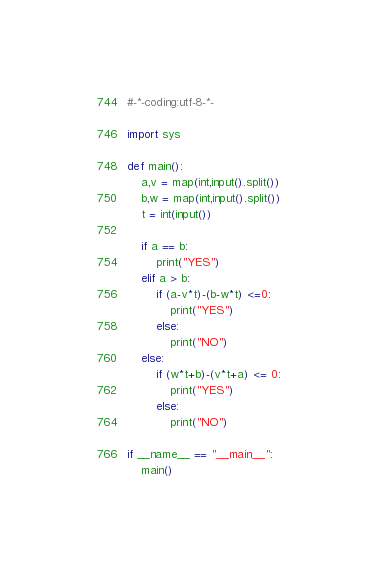Convert code to text. <code><loc_0><loc_0><loc_500><loc_500><_Python_>#-*-coding:utf-8-*-

import sys

def main():
    a,v = map(int,input().split())
    b,w = map(int,input().split())
    t = int(input())

    if a == b:
        print("YES")
    elif a > b:
        if (a-v*t)-(b-w*t) <=0:
            print("YES")
        else:
            print("NO")
    else:
        if (w*t+b)-(v*t+a) <= 0:
            print("YES")
        else:
            print("NO")

if __name__ == "__main__":
    main()</code> 